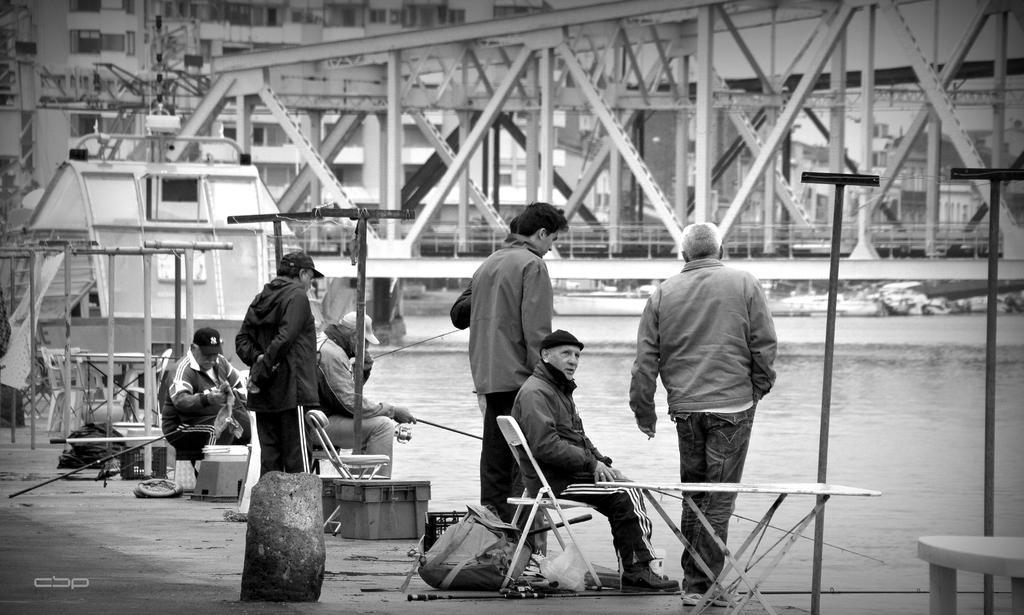How would you summarize this image in a sentence or two? In the image I can see three people who are sitting on the chairs and also I can see some other people standing, chairs, tables and some water and poles. 